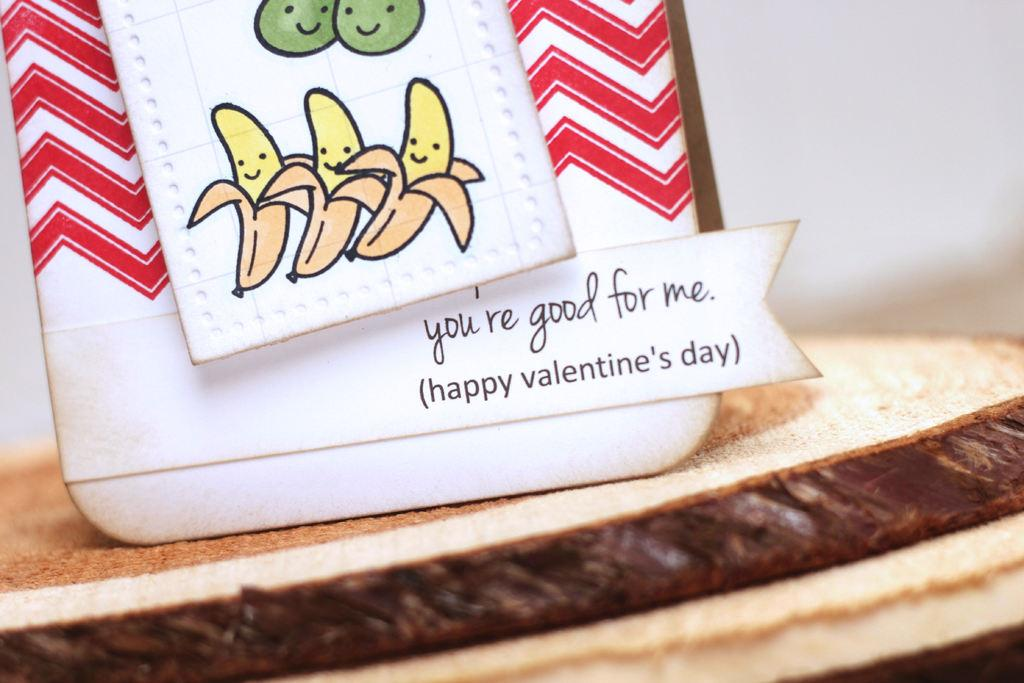What is the main object in the picture? There is a personalized gift card in the picture. What can be found on the gift card? There is text on the gift card. From what surface does the picture appear to be taken? The image appears to be taken from a table or a similar surface at the bottom. Is there a ghost visible in the picture? No, there is no ghost present in the image. What type of cloth is draped over the gift card in the picture? There is no cloth draped over the gift card in the image. 